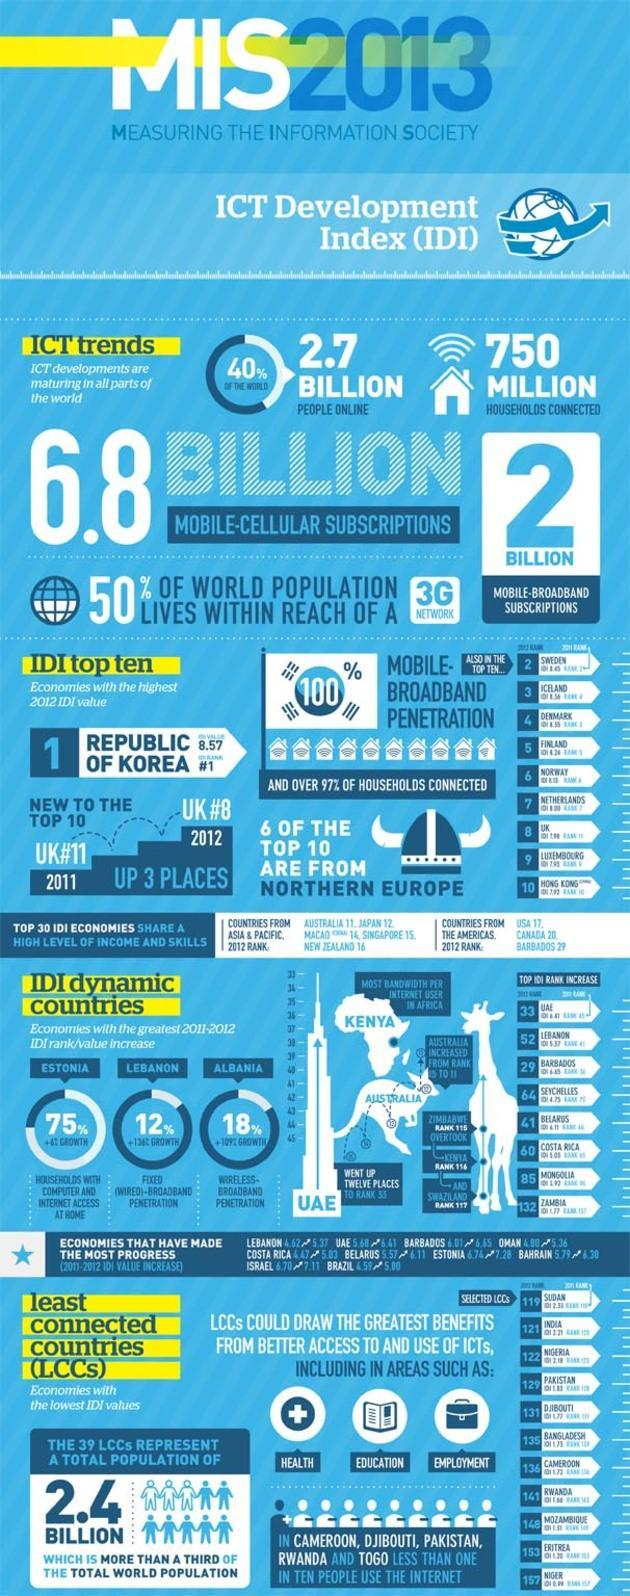What is the number of mobile-broadband subscriptions in the world in 2013?
Answer the question with a short phrase. 2 BILLION Which country has the most bandwidth per internet user in Africa? KENYA What is the IDI rank of UK in 2012? 8 Which country has 100% mobile broadband penetration in 2012? REPUBLIC OF KOREA Which country has the third IDI rank in 2012? ICELAND 